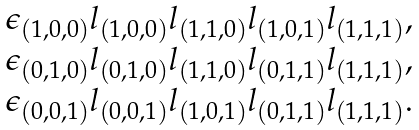<formula> <loc_0><loc_0><loc_500><loc_500>\begin{array} { l } \epsilon _ { ( 1 , 0 , 0 ) } l _ { ( 1 , 0 , 0 ) } l _ { ( 1 , 1 , 0 ) } l _ { ( 1 , 0 , 1 ) } l _ { ( 1 , 1 , 1 ) } , \\ \epsilon _ { ( 0 , 1 , 0 ) } l _ { ( 0 , 1 , 0 ) } l _ { ( 1 , 1 , 0 ) } l _ { ( 0 , 1 , 1 ) } l _ { ( 1 , 1 , 1 ) } , \\ \epsilon _ { ( 0 , 0 , 1 ) } l _ { ( 0 , 0 , 1 ) } l _ { ( 1 , 0 , 1 ) } l _ { ( 0 , 1 , 1 ) } l _ { ( 1 , 1 , 1 ) } . \end{array}</formula> 